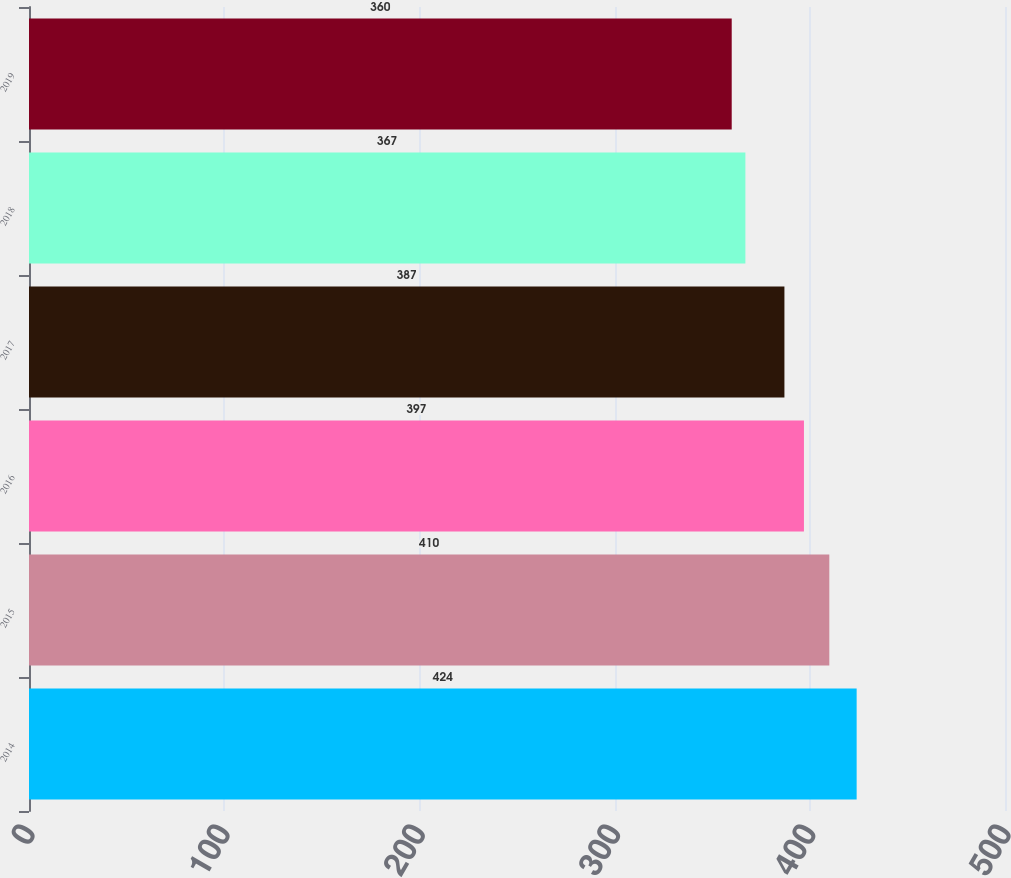Convert chart. <chart><loc_0><loc_0><loc_500><loc_500><bar_chart><fcel>2014<fcel>2015<fcel>2016<fcel>2017<fcel>2018<fcel>2019<nl><fcel>424<fcel>410<fcel>397<fcel>387<fcel>367<fcel>360<nl></chart> 